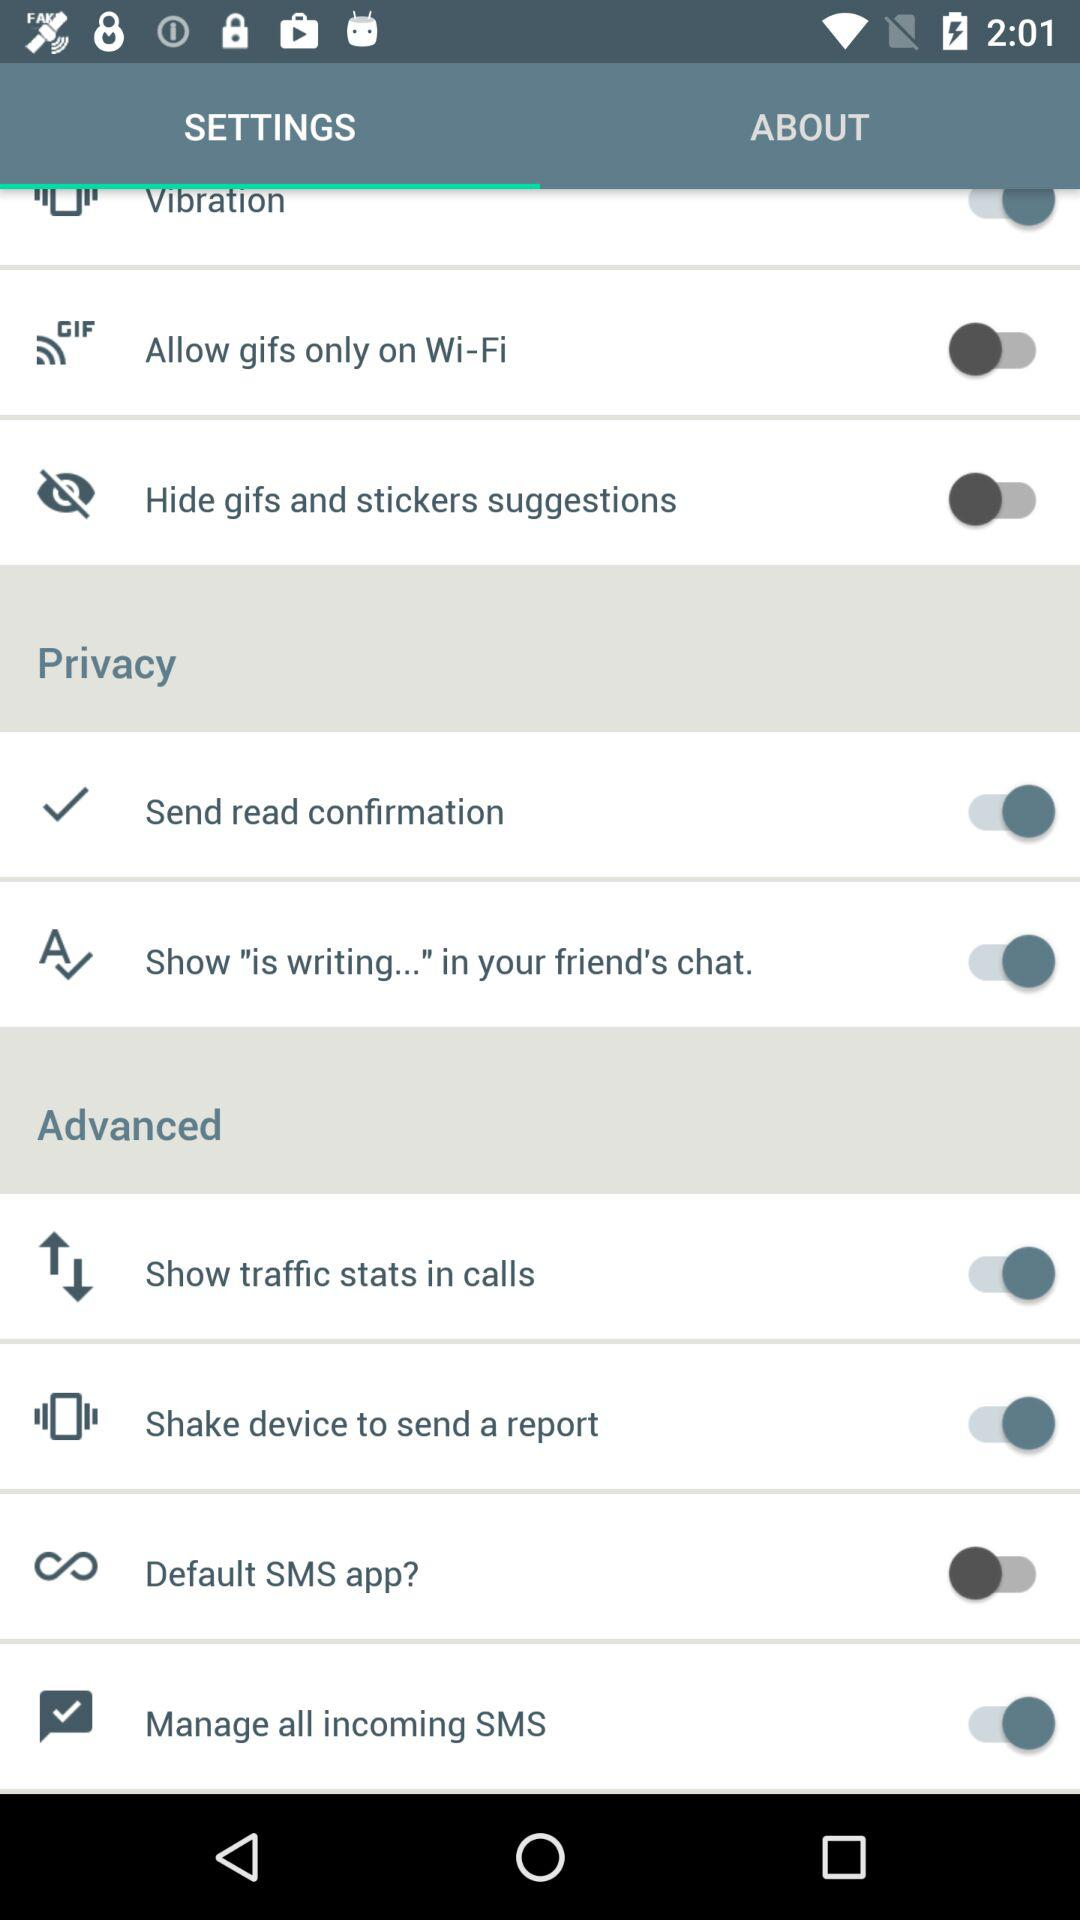What's the status of "Show traffic stats in calls"? The status is "on". 